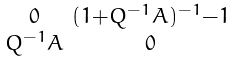Convert formula to latex. <formula><loc_0><loc_0><loc_500><loc_500>\begin{smallmatrix} 0 & ( 1 + Q ^ { - 1 } A ) ^ { - 1 } - 1 \\ Q ^ { - 1 } A & 0 \end{smallmatrix}</formula> 